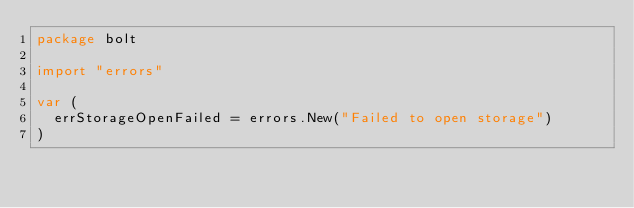<code> <loc_0><loc_0><loc_500><loc_500><_Go_>package bolt

import "errors"

var (
	errStorageOpenFailed = errors.New("Failed to open storage")
)
</code> 